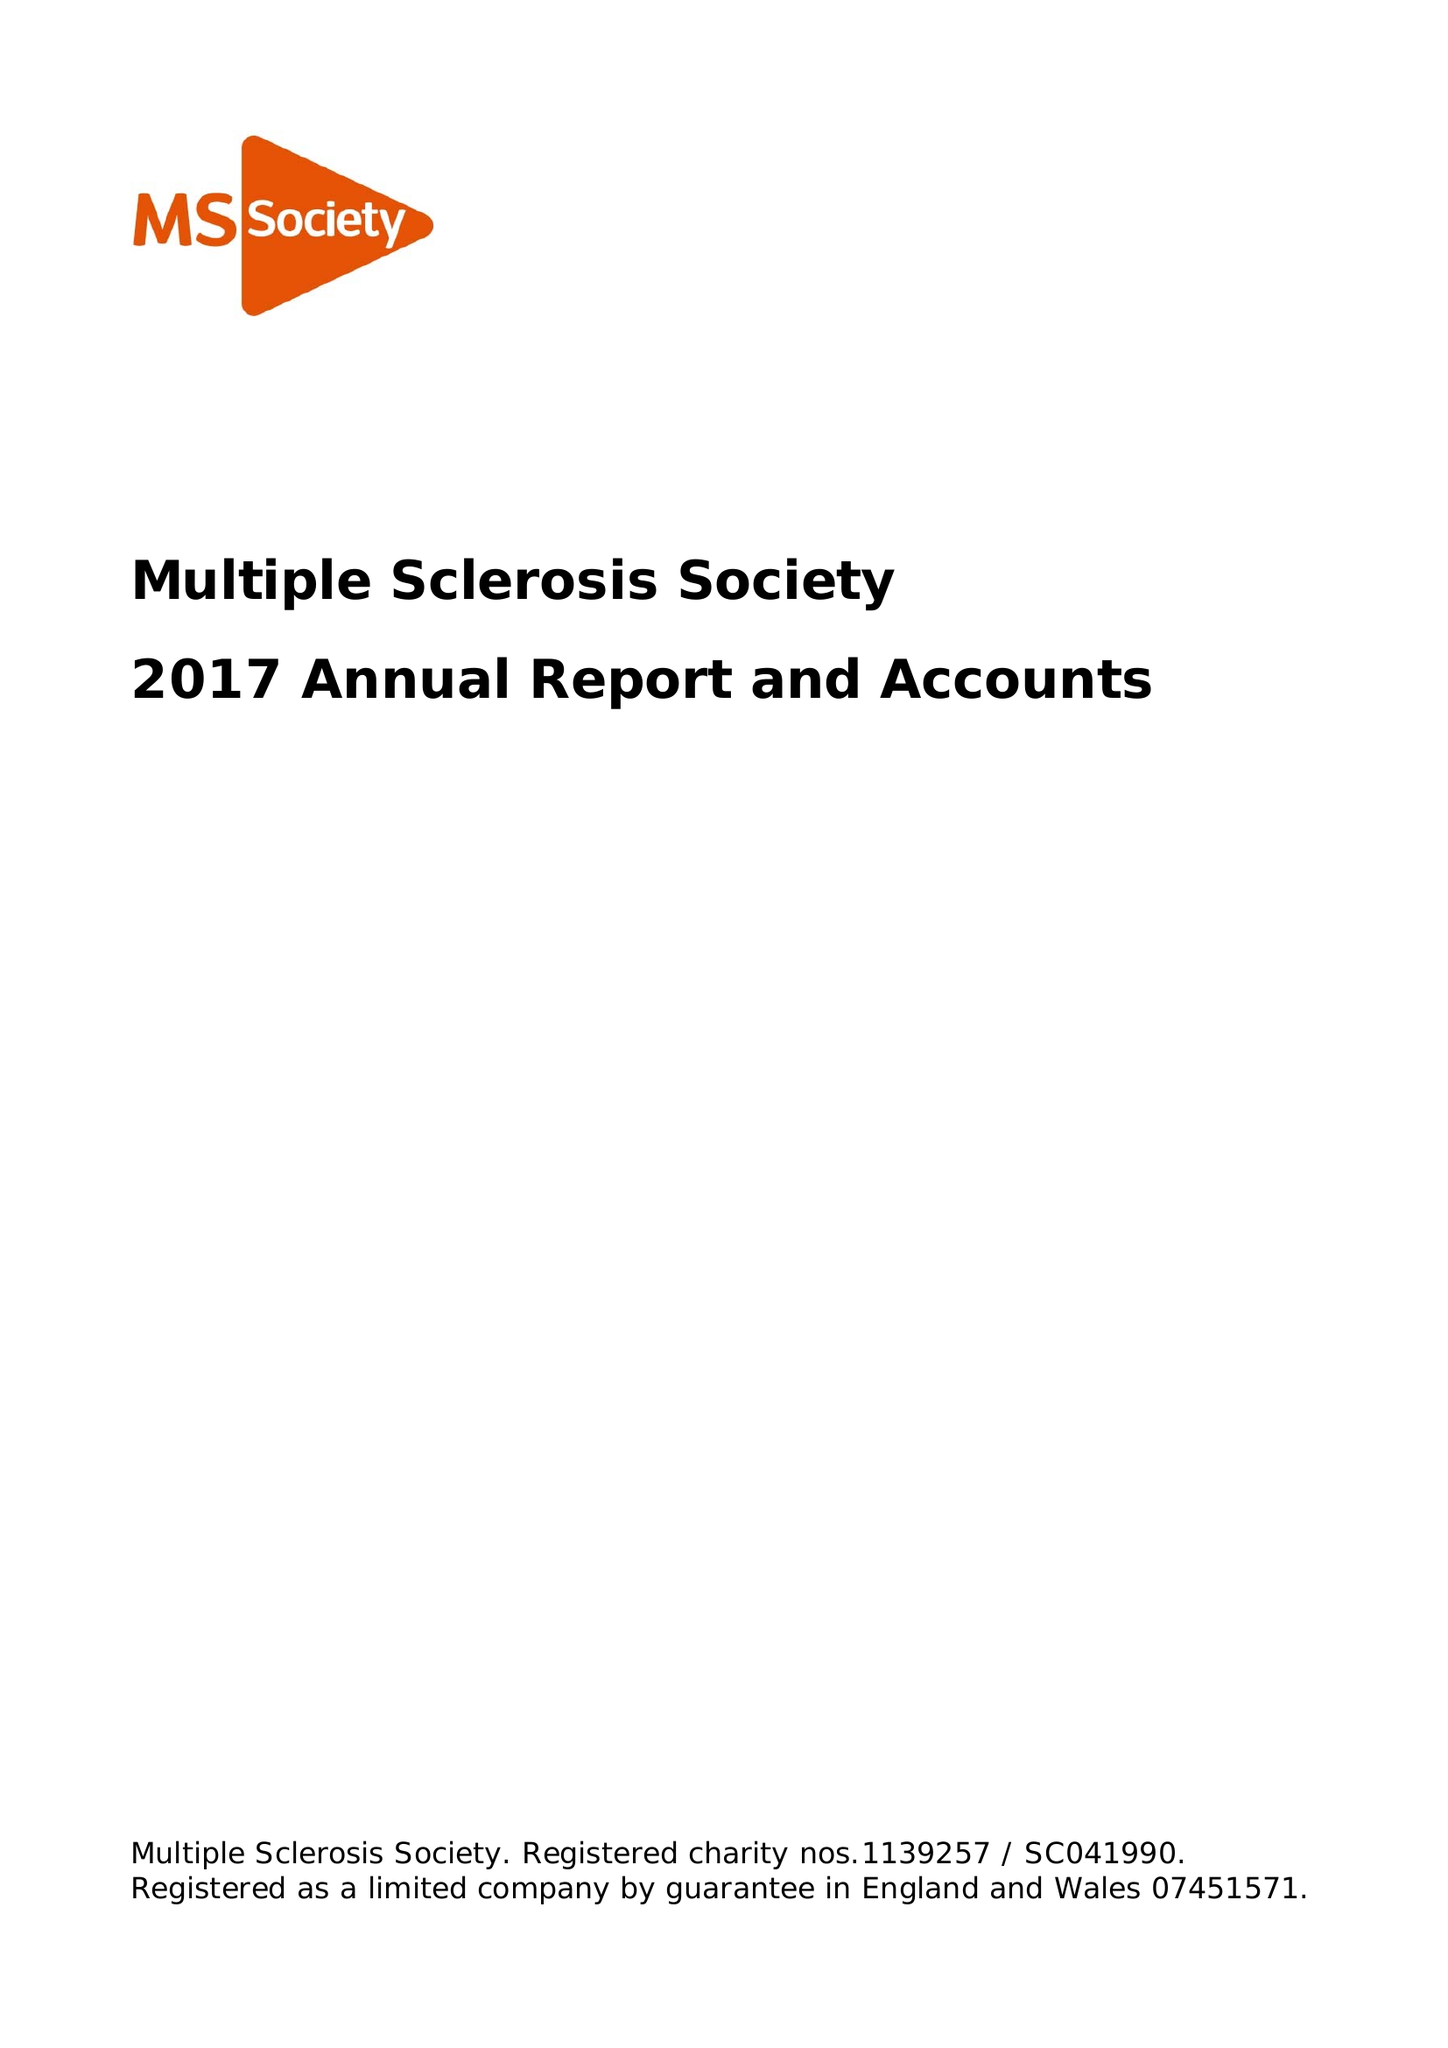What is the value for the spending_annually_in_british_pounds?
Answer the question using a single word or phrase. 28802000.00 